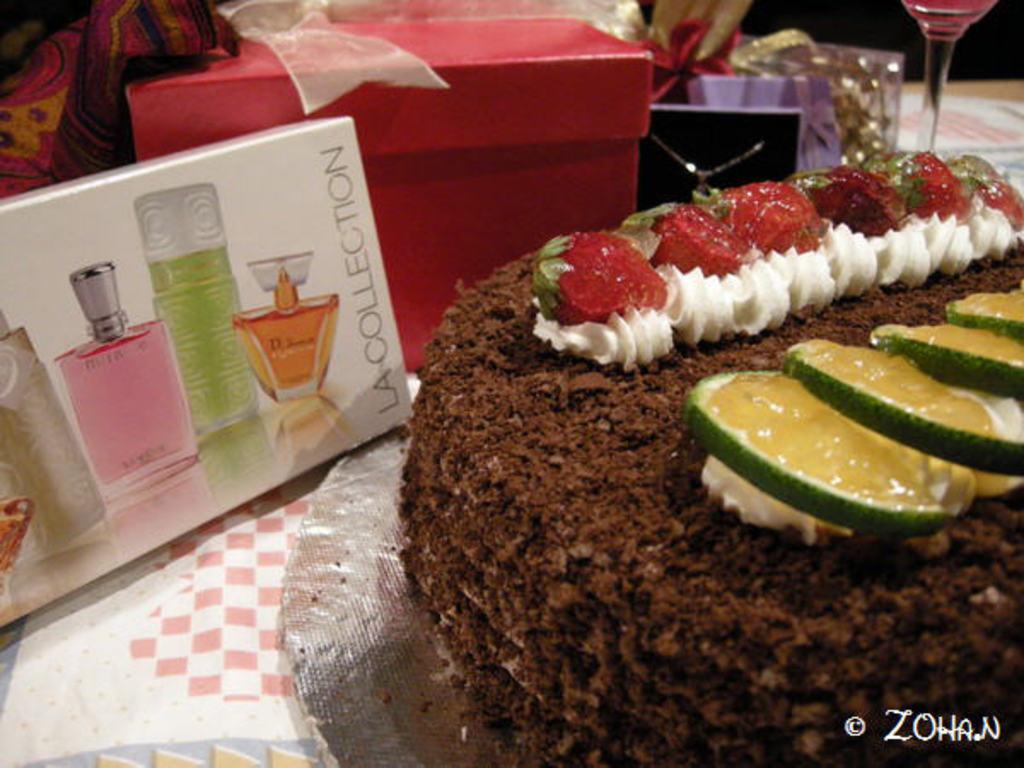What name of the perfume brand?
Offer a very short reply. La collection. 